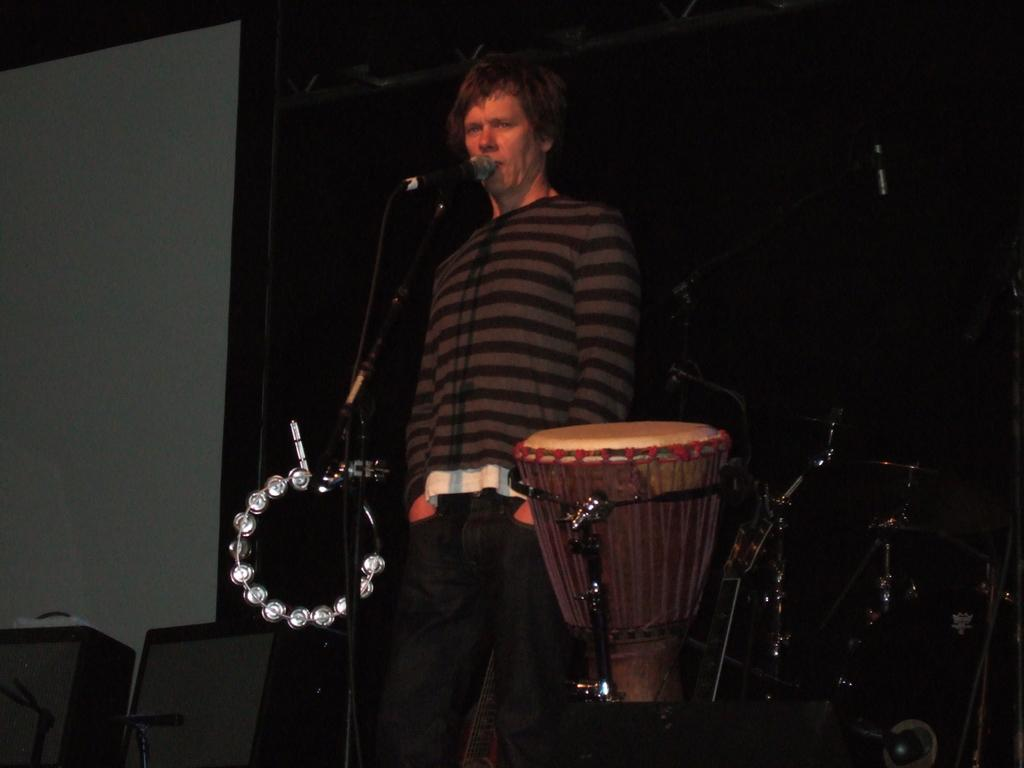What is the main subject of the image? The main subject of the image is a man. What is the man doing in the image? The man is standing and singing in the image. What object is the man holding in the image? The man is holding a microphone in the image. What other musical instrument can be seen in the image? There is a drum beside the man in the image. What type of suit is the man wearing in the image? The man is not wearing a suit in the image; he is dressed casually. Can you see a guitar in the image? No, there is no guitar present in the image. 